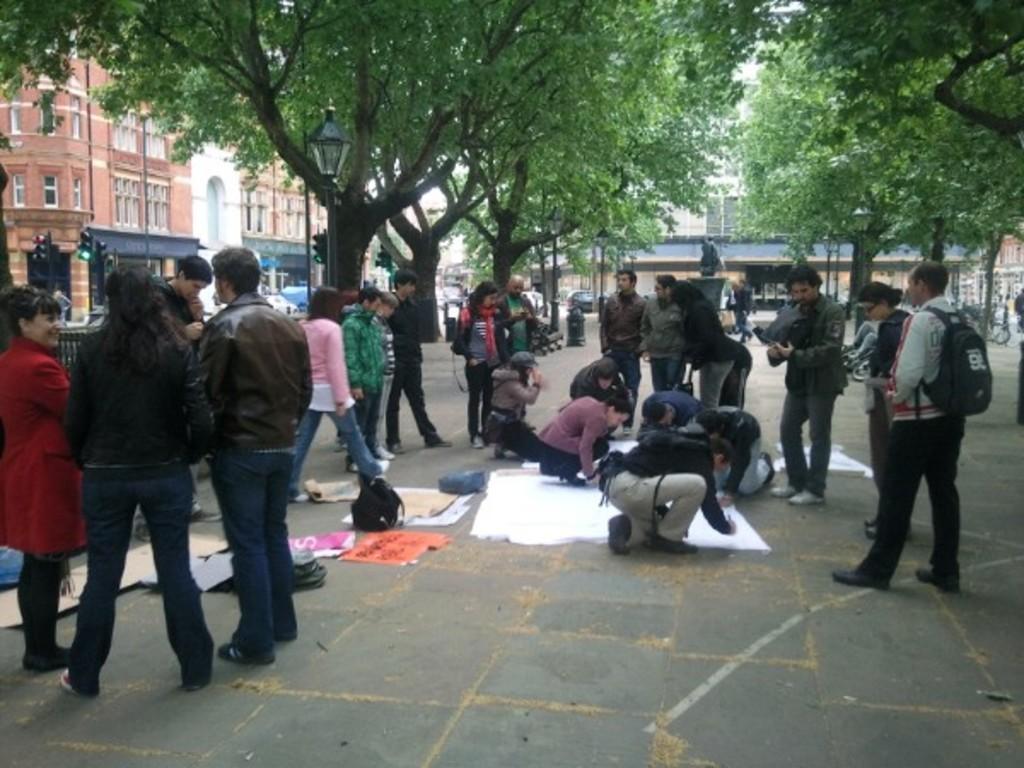How would you summarize this image in a sentence or two? In this image there is path, on that path people are doing different activities, on either side of the path there are green trees and pole, in the middle there is a statute and building, in the left side there is a building and signal poles , there is a road on that road few vehicles are moving. 